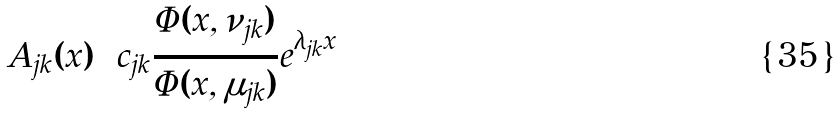<formula> <loc_0><loc_0><loc_500><loc_500>A _ { j k } ( x ) = c _ { j k } \frac { \Phi ( x , \nu _ { j k } ) } { \Phi ( x , \mu _ { j k } ) } e ^ { \lambda _ { j k } x }</formula> 